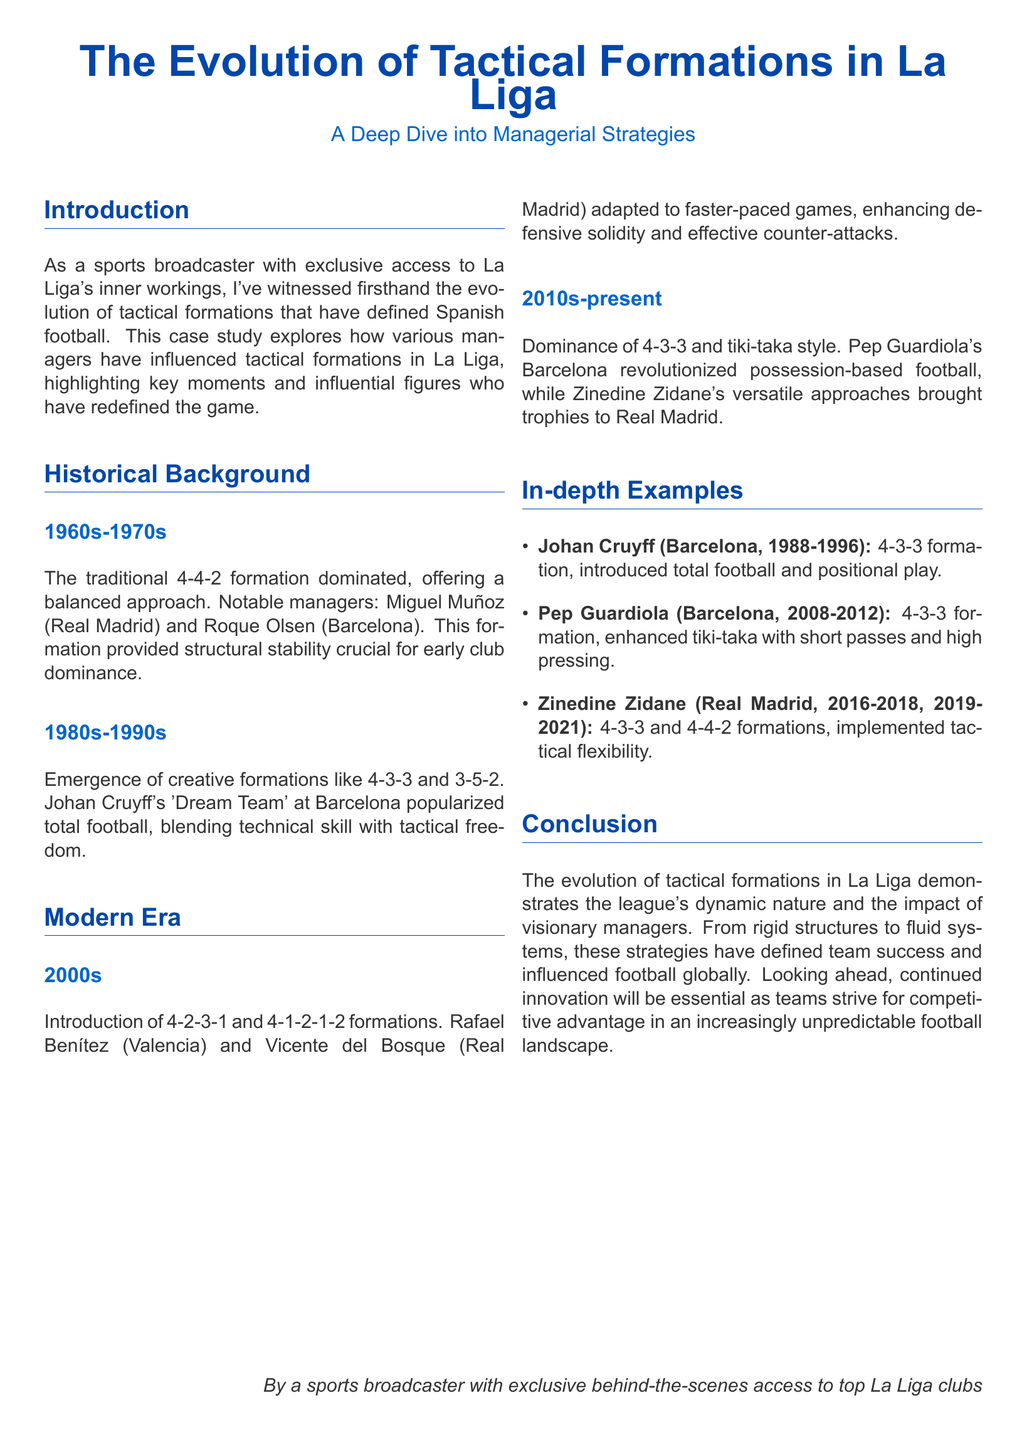What formation dominated La Liga in the 1960s and 1970s? The formation that dominated was the 4-4-2, which provided structural stability.
Answer: 4-4-2 Who popularized total football at Barcelona? Johan Cruyff was pivotal in popularizing total football with the 4-3-3 formation.
Answer: Johan Cruyff Which two formations were introduced in the 2000s? The 4-2-3-1 and 4-1-2-1-2 formations were introduced during this period.
Answer: 4-2-3-1 and 4-1-2-1-2 What tactical style was revolutionized by Pep Guardiola at Barcelona? Pep Guardiola revolutionized possession-based football emphasized through the tiki-taka style.
Answer: Tiki-taka Which manager's approach included tactical flexibility? Zinedine Zidane implemented tactical flexibility with both 4-3-3 and 4-4-2 formations.
Answer: Zinedine Zidane What has characterized the evolution of tactical formations in La Liga? The evolution has been characterized by a shift from rigid structures to fluid systems.
Answer: Shift from rigid to fluid What is the time span covered in the "Modern Era" section of the document? The "Modern Era" section discusses the period from the 2000s to the present.
Answer: 2000s-present What type of football is associated with Pep Guardiola's strategy? Pep Guardiola's strategy is characterized by possession-based football.
Answer: Possession-based football When did Johan Cruyff manage Barcelona? Johan Cruyff managed Barcelona from 1988 to 1996.
Answer: 1988-1996 